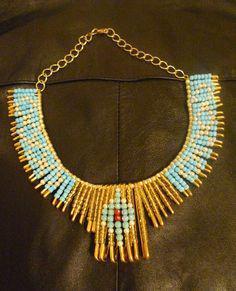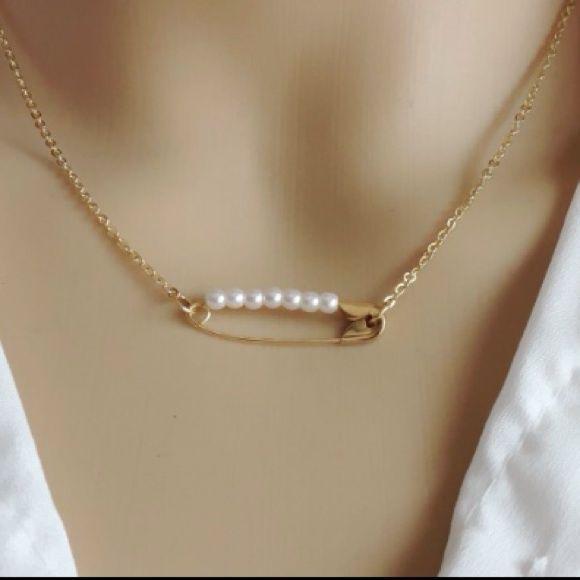The first image is the image on the left, the second image is the image on the right. Given the left and right images, does the statement "Both images show a model wearing a necklace." hold true? Answer yes or no. No. The first image is the image on the left, the second image is the image on the right. Assess this claim about the two images: "One of the necklaces is not dangling around a neck.". Correct or not? Answer yes or no. Yes. 